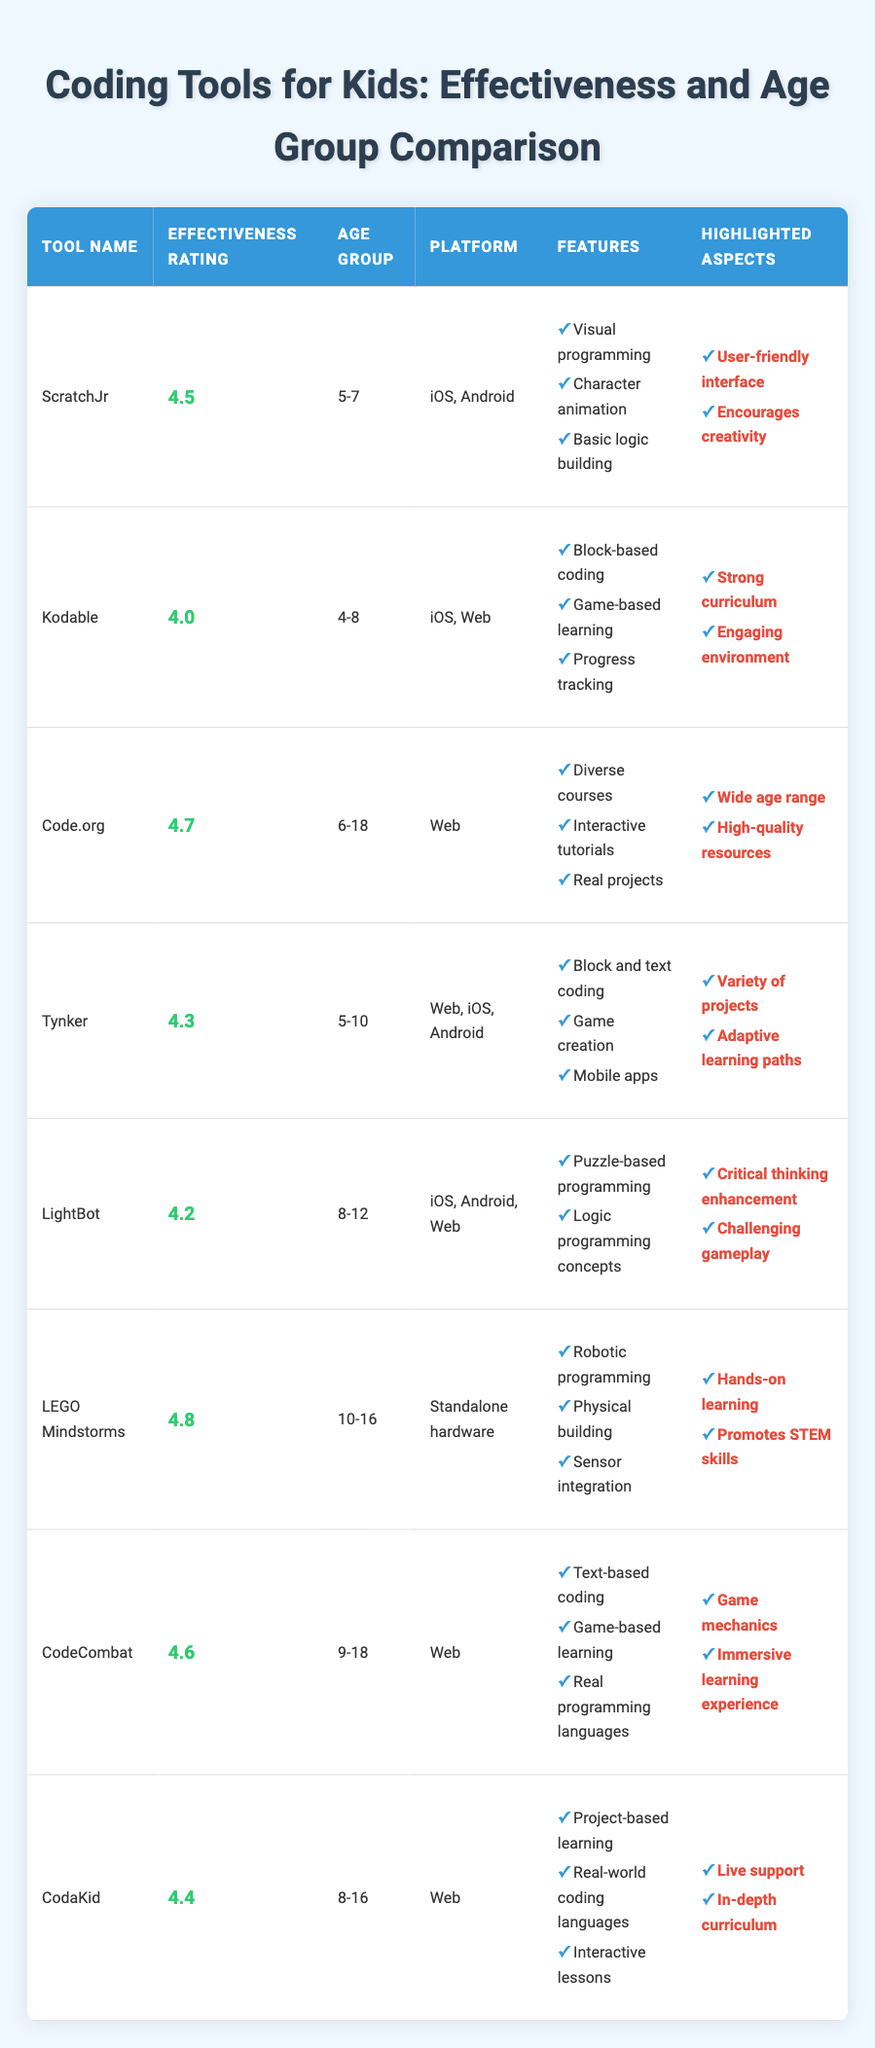What is the effectiveness rating of ScratchJr? The table directly lists the effectiveness rating of ScratchJr as 4.5.
Answer: 4.5 What age group is Kodable designed for? The table specifies that Kodable is designed for the age group 4-8.
Answer: 4-8 Which tool has the highest effectiveness rating? Comparing all effectiveness ratings in the table, LEGO Mindstorms has the highest rating at 4.8.
Answer: LEGO Mindstorms How many tools are designed for the age group 8-16? The table indicates two tools, CodaKid and LEGO Mindstorms, are designed for the age group 8-16.
Answer: 2 Is Code.org effective for ages younger than 6? The age group for Code.org is listed as 6-18, so it is not effective for anyone younger than 6.
Answer: No What is the average effectiveness rating of tools suitable for ages 5-10? The effectiveness ratings for ScratchJr (4.5), Tynker (4.3), and LightBot (4.2) can be averaged: (4.5 + 4.3 + 4.2) / 3 = 4.333.
Answer: 4.33 What platform does CodeCombat operate on? The table shows that CodeCombat operates on the Web platform.
Answer: Web Does LightBot enhance critical thinking skills? The table highlights critical thinking enhancement as a feature of LightBot, confirming it does.
Answer: Yes Which tool has features for both block and text coding? Tynker is indicated in the table as having features for both block and text coding.
Answer: Tynker If we consider the effectiveness ratings of all tools, what is the median effectiveness rating? The sorted effectiveness ratings are: 4.0, 4.2, 4.3, 4.4, 4.5, 4.6, 4.7, 4.8. The median (average of the two middle numbers) is (4.4 + 4.5) / 2 = 4.45.
Answer: 4.45 How many tools are available on iOS? The tools listed as available on iOS are ScratchJr, Tynker, LightBot, and LEGO Mindstorms, totaling 4 tools.
Answer: 4 Which tool is focused on robotic programming? The table indicates that LEGO Mindstorms is focused on robotic programming.
Answer: LEGO Mindstorms Does CodaKid provide live support? The highlighted aspects in the table state that CodaKid provides live support.
Answer: Yes What feature does Code.org offer that makes it suitable for a wide age range? The table lists "Wide age range" as a highlighted aspect of Code.org, indicating its suitability for a broader age range.
Answer: Wide age range Which tool has the lowest effectiveness rating among them? The table shows Kodable with an effectiveness rating of 4.0, the lowest among all listed tools.
Answer: Kodable What is one highlighted aspect of LEGO Mindstorms? The table notes "Hands-on learning" as one highlighted aspect of LEGO Mindstorms.
Answer: Hands-on learning 